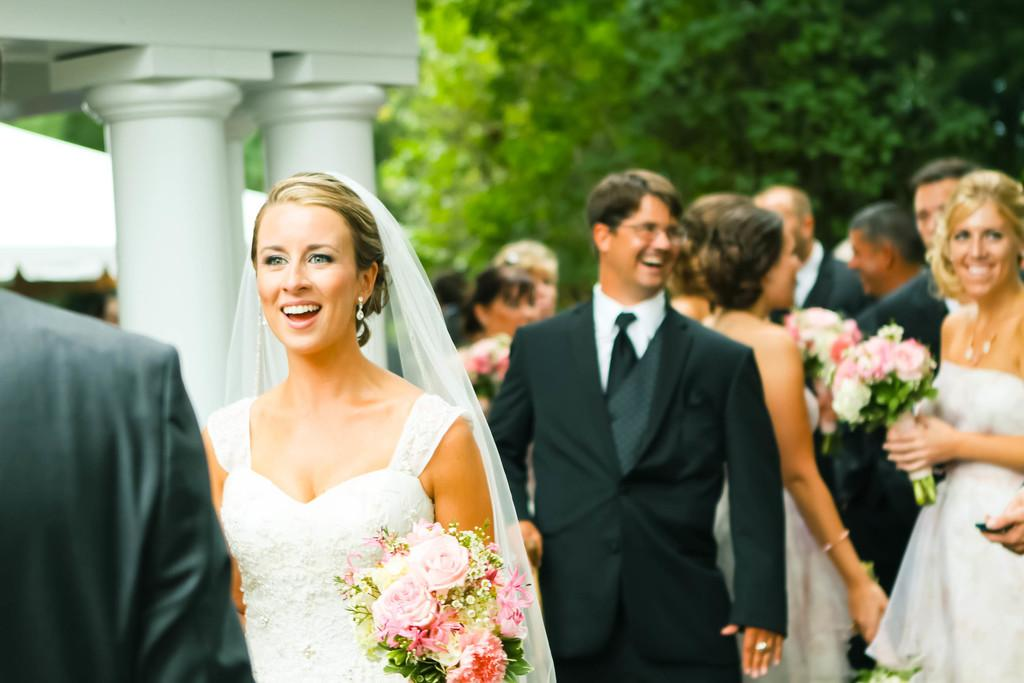What are the people in the image doing? The people in the image are standing. What are some of the people holding? Some of the people are holding flower bouquets. What can be seen in the background of the image? There are trees and pillars visible in the background of the image. How many spoons can be seen in the image? There are no spoons visible in the image. What type of lace is draped over the trees in the background? There is no lace present in the image; it only features trees and pillars in the background. 